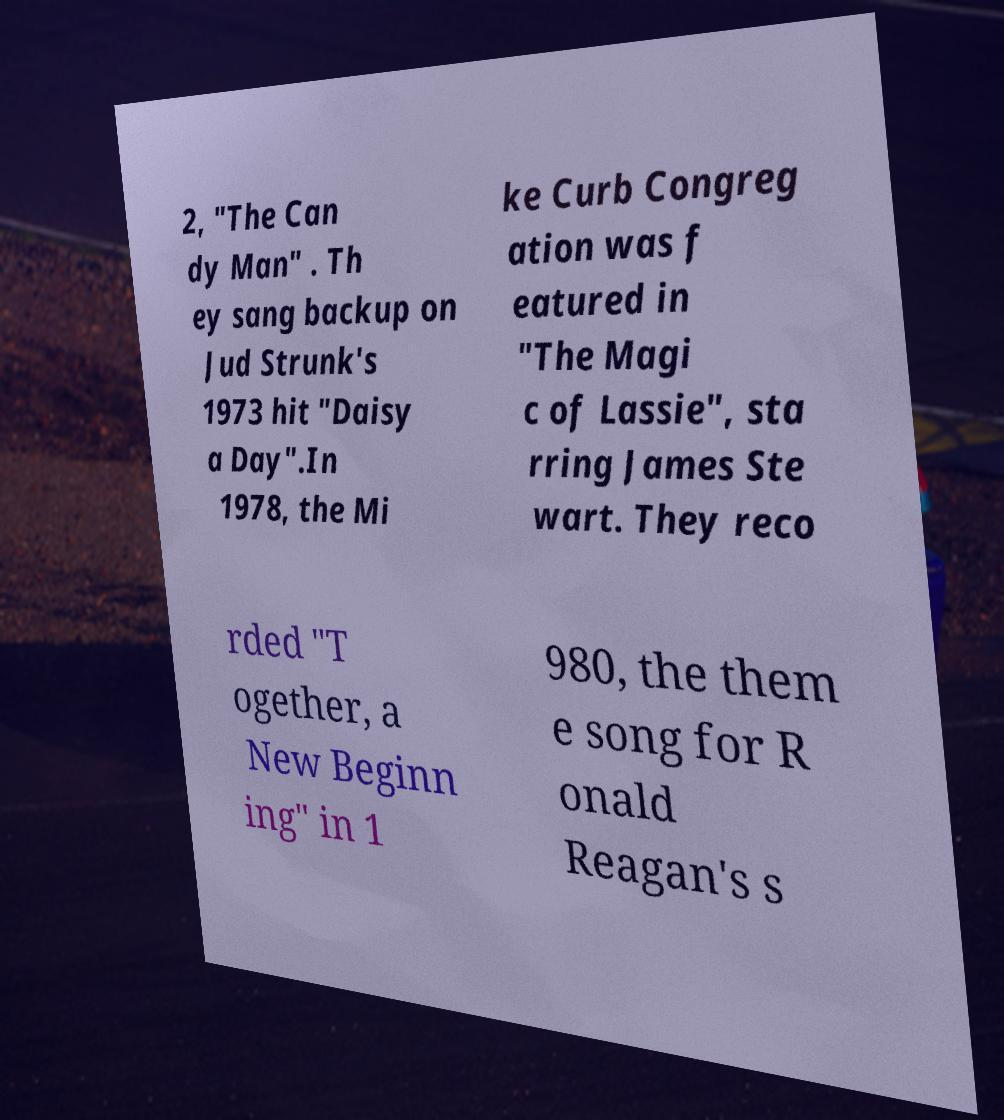Could you extract and type out the text from this image? 2, "The Can dy Man" . Th ey sang backup on Jud Strunk's 1973 hit "Daisy a Day".In 1978, the Mi ke Curb Congreg ation was f eatured in "The Magi c of Lassie", sta rring James Ste wart. They reco rded "T ogether, a New Beginn ing" in 1 980, the them e song for R onald Reagan's s 